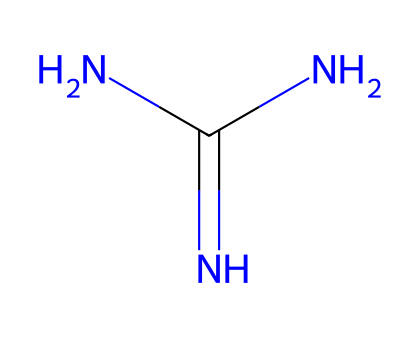What is the molecular formula of this chemical? The SMILES representation NC(=N)N indicates the atoms present: 1 nitrogen in the amine group, 2 nitrogens in the imine group, and 1 carbon, leading to the formula of C1H7N5.
Answer: C1H7N5 How many nitrogen atoms are in the structure? Counting the nitrogen (N) symbols in the SMILES representation NC(=N)N shows there are a total of 3 nitrogen atoms.
Answer: 3 What type of bonding is primarily present in this molecule? The structure shows resonance and multiple bonding between the nitrogen and carbon atoms, indicating that it has a significant amount of covalent bonding.
Answer: covalent What role does guanidine play in acid-base reactions? Guanidine, with its strong basicity due to the resonance stabilization of its conjugate acid, plays the role of a strong superbase in reactions with proton donors.
Answer: superbase How does the presence of multiple nitrogen atoms affect the basicity of guanidine? The three nitrogen atoms create electron-donating effects and provide resonance stabilization to the positive charge, increasing the basicity of guanidine compared to other amines.
Answer: increases basicity What functional groups can you identify in guanidine? The SMILES representation shows that guanidine has amine (-NH2) and imine (=NH) functional groups, making it a diaminomethane derivative.
Answer: amine and imine What is the hybridization state of the central carbon atom in guanidine? The central carbon atom is bonded to three nitrogen atoms and holds a trigonal planar arrangement, indicating it is sp2 hybridized.
Answer: sp2 